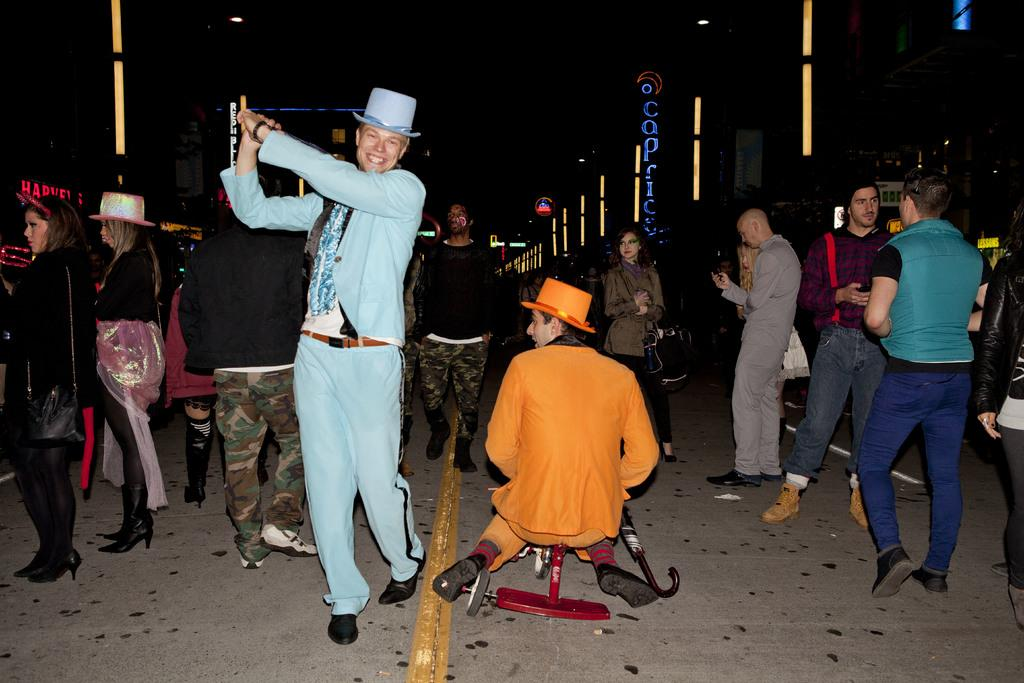What are the people in the image doing? The persons in the image are standing on the road. What can be seen in the background of the image? There are buildings on either side of the image. Are there any lights visible in the image? Yes, there are two lights visible at the top of the image. What type of mint is growing on the tree in the image? There is no mint or tree present in the image. What country is depicted in the image? The image does not depict a specific country; it only shows persons standing on a road with buildings in the background. 